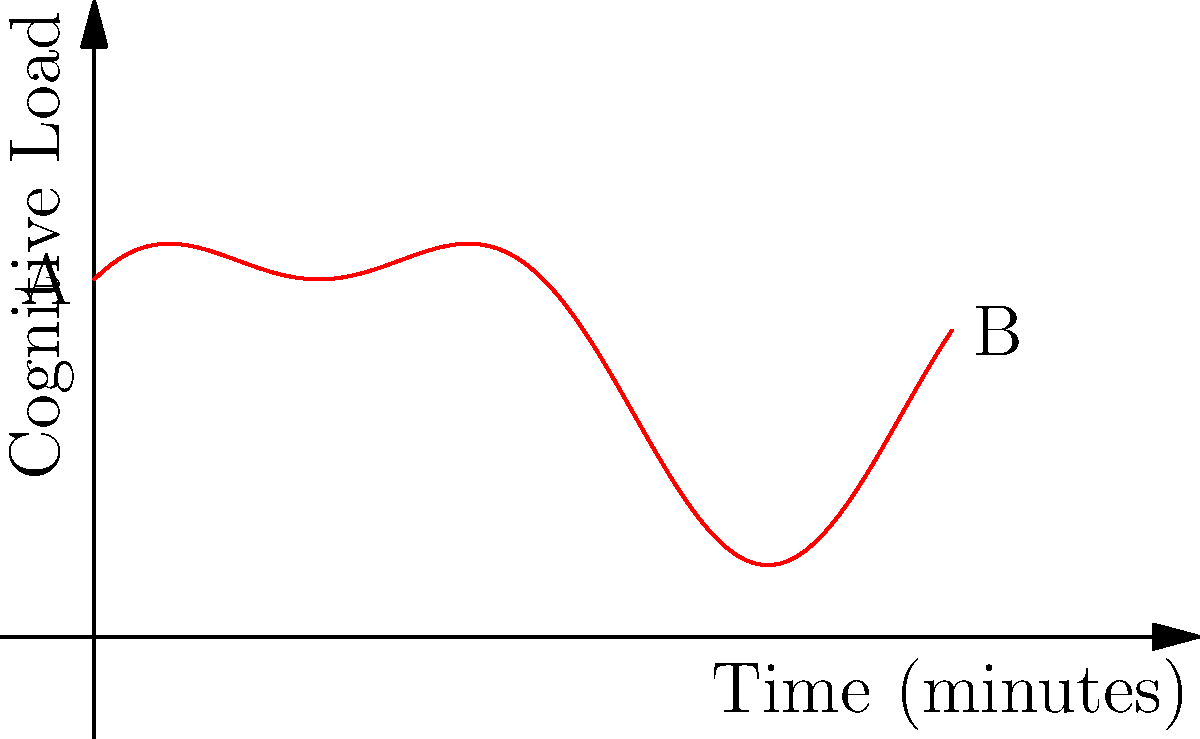As a researcher following in the footsteps of Professor Carolyn Rovee-Collier, you're studying cognitive load during a series of memory tasks. The graph represents the cognitive load $f(t)$ over a 6-minute period. The function is given by $f(t) = 2 + \sin(t) + 0.5\cos(2t)$, where $t$ is time in minutes. Calculate the total cognitive load experienced during this period, represented by the area under the curve from A to B. To calculate the total cognitive load, we need to integrate the function $f(t)$ from 0 to 6:

1) Set up the integral:
   $$\int_0^6 (2 + \sin(t) + 0.5\cos(2t)) dt$$

2) Integrate each term separately:
   
   a) $\int 2 dt = 2t$
   
   b) $\int \sin(t) dt = -\cos(t)$
   
   c) $\int 0.5\cos(2t) dt = 0.25\sin(2t)$

3) Apply the fundamental theorem of calculus:
   $$[2t - \cos(t) + 0.25\sin(2t)]_0^6$$

4) Evaluate at the upper and lower bounds:
   $$(12 - \cos(6) + 0.25\sin(12)) - (0 - \cos(0) + 0.25\sin(0))$$

5) Simplify:
   $$12 - \cos(6) + 0.25\sin(12) + 1$$
   $$= 13 - \cos(6) + 0.25\sin(12)$$

6) Calculate the final value (you can use a calculator for this step):
   $$\approx 13.78$$

This value represents the total cognitive load experienced during the 6-minute task period.
Answer: $13.78$ (units of cognitive load × minutes) 